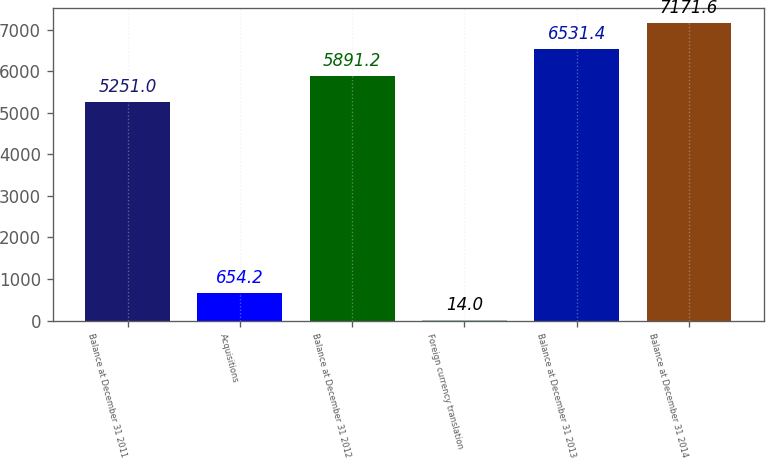Convert chart. <chart><loc_0><loc_0><loc_500><loc_500><bar_chart><fcel>Balance at December 31 2011<fcel>Acquisitions<fcel>Balance at December 31 2012<fcel>Foreign currency translation<fcel>Balance at December 31 2013<fcel>Balance at December 31 2014<nl><fcel>5251<fcel>654.2<fcel>5891.2<fcel>14<fcel>6531.4<fcel>7171.6<nl></chart> 